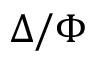<formula> <loc_0><loc_0><loc_500><loc_500>\Delta / \Phi</formula> 